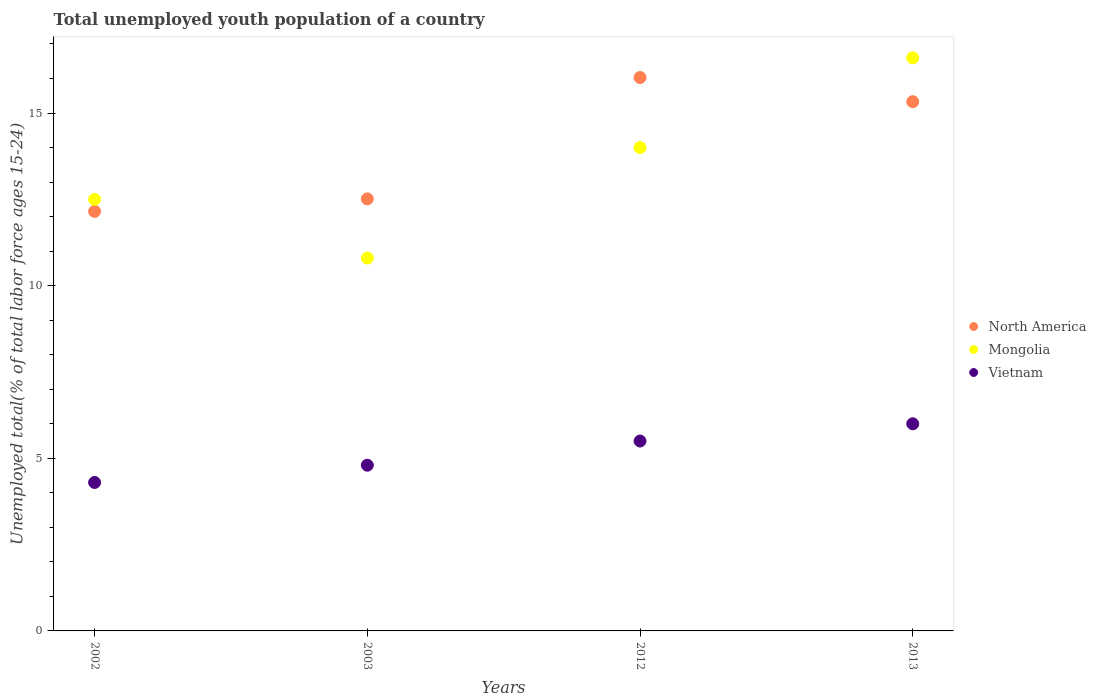Across all years, what is the maximum percentage of total unemployed youth population of a country in North America?
Your response must be concise. 16.03. Across all years, what is the minimum percentage of total unemployed youth population of a country in Mongolia?
Keep it short and to the point. 10.8. In which year was the percentage of total unemployed youth population of a country in Vietnam maximum?
Your answer should be compact. 2013. What is the total percentage of total unemployed youth population of a country in Vietnam in the graph?
Your answer should be very brief. 20.6. What is the difference between the percentage of total unemployed youth population of a country in Vietnam in 2003 and that in 2013?
Provide a short and direct response. -1.2. What is the difference between the percentage of total unemployed youth population of a country in Mongolia in 2013 and the percentage of total unemployed youth population of a country in North America in 2012?
Keep it short and to the point. 0.57. What is the average percentage of total unemployed youth population of a country in Vietnam per year?
Offer a terse response. 5.15. In the year 2002, what is the difference between the percentage of total unemployed youth population of a country in North America and percentage of total unemployed youth population of a country in Mongolia?
Offer a very short reply. -0.35. In how many years, is the percentage of total unemployed youth population of a country in North America greater than 11 %?
Give a very brief answer. 4. What is the ratio of the percentage of total unemployed youth population of a country in North America in 2002 to that in 2003?
Provide a short and direct response. 0.97. Is the difference between the percentage of total unemployed youth population of a country in North America in 2003 and 2013 greater than the difference between the percentage of total unemployed youth population of a country in Mongolia in 2003 and 2013?
Provide a succinct answer. Yes. What is the difference between the highest and the second highest percentage of total unemployed youth population of a country in Mongolia?
Make the answer very short. 2.6. What is the difference between the highest and the lowest percentage of total unemployed youth population of a country in Mongolia?
Make the answer very short. 5.8. In how many years, is the percentage of total unemployed youth population of a country in North America greater than the average percentage of total unemployed youth population of a country in North America taken over all years?
Offer a very short reply. 2. Does the percentage of total unemployed youth population of a country in Mongolia monotonically increase over the years?
Give a very brief answer. No. Is the percentage of total unemployed youth population of a country in North America strictly greater than the percentage of total unemployed youth population of a country in Mongolia over the years?
Give a very brief answer. No. Does the graph contain grids?
Your answer should be compact. No. Where does the legend appear in the graph?
Give a very brief answer. Center right. What is the title of the graph?
Your answer should be compact. Total unemployed youth population of a country. What is the label or title of the Y-axis?
Offer a very short reply. Unemployed total(% of total labor force ages 15-24). What is the Unemployed total(% of total labor force ages 15-24) in North America in 2002?
Give a very brief answer. 12.15. What is the Unemployed total(% of total labor force ages 15-24) in Vietnam in 2002?
Your response must be concise. 4.3. What is the Unemployed total(% of total labor force ages 15-24) in North America in 2003?
Make the answer very short. 12.51. What is the Unemployed total(% of total labor force ages 15-24) of Mongolia in 2003?
Offer a very short reply. 10.8. What is the Unemployed total(% of total labor force ages 15-24) in Vietnam in 2003?
Your answer should be very brief. 4.8. What is the Unemployed total(% of total labor force ages 15-24) in North America in 2012?
Make the answer very short. 16.03. What is the Unemployed total(% of total labor force ages 15-24) of Mongolia in 2012?
Keep it short and to the point. 14. What is the Unemployed total(% of total labor force ages 15-24) in North America in 2013?
Provide a short and direct response. 15.33. What is the Unemployed total(% of total labor force ages 15-24) of Mongolia in 2013?
Provide a short and direct response. 16.6. What is the Unemployed total(% of total labor force ages 15-24) of Vietnam in 2013?
Give a very brief answer. 6. Across all years, what is the maximum Unemployed total(% of total labor force ages 15-24) in North America?
Keep it short and to the point. 16.03. Across all years, what is the maximum Unemployed total(% of total labor force ages 15-24) in Mongolia?
Provide a succinct answer. 16.6. Across all years, what is the minimum Unemployed total(% of total labor force ages 15-24) of North America?
Make the answer very short. 12.15. Across all years, what is the minimum Unemployed total(% of total labor force ages 15-24) in Mongolia?
Offer a very short reply. 10.8. Across all years, what is the minimum Unemployed total(% of total labor force ages 15-24) in Vietnam?
Provide a succinct answer. 4.3. What is the total Unemployed total(% of total labor force ages 15-24) in North America in the graph?
Ensure brevity in your answer.  56.02. What is the total Unemployed total(% of total labor force ages 15-24) of Mongolia in the graph?
Keep it short and to the point. 53.9. What is the total Unemployed total(% of total labor force ages 15-24) of Vietnam in the graph?
Ensure brevity in your answer.  20.6. What is the difference between the Unemployed total(% of total labor force ages 15-24) of North America in 2002 and that in 2003?
Your response must be concise. -0.36. What is the difference between the Unemployed total(% of total labor force ages 15-24) in North America in 2002 and that in 2012?
Provide a succinct answer. -3.88. What is the difference between the Unemployed total(% of total labor force ages 15-24) in North America in 2002 and that in 2013?
Ensure brevity in your answer.  -3.18. What is the difference between the Unemployed total(% of total labor force ages 15-24) of Vietnam in 2002 and that in 2013?
Provide a succinct answer. -1.7. What is the difference between the Unemployed total(% of total labor force ages 15-24) in North America in 2003 and that in 2012?
Your response must be concise. -3.52. What is the difference between the Unemployed total(% of total labor force ages 15-24) of Mongolia in 2003 and that in 2012?
Your answer should be very brief. -3.2. What is the difference between the Unemployed total(% of total labor force ages 15-24) of North America in 2003 and that in 2013?
Provide a short and direct response. -2.82. What is the difference between the Unemployed total(% of total labor force ages 15-24) of Mongolia in 2003 and that in 2013?
Your response must be concise. -5.8. What is the difference between the Unemployed total(% of total labor force ages 15-24) of North America in 2012 and that in 2013?
Ensure brevity in your answer.  0.7. What is the difference between the Unemployed total(% of total labor force ages 15-24) of Mongolia in 2012 and that in 2013?
Keep it short and to the point. -2.6. What is the difference between the Unemployed total(% of total labor force ages 15-24) of Vietnam in 2012 and that in 2013?
Your answer should be compact. -0.5. What is the difference between the Unemployed total(% of total labor force ages 15-24) in North America in 2002 and the Unemployed total(% of total labor force ages 15-24) in Mongolia in 2003?
Your answer should be very brief. 1.35. What is the difference between the Unemployed total(% of total labor force ages 15-24) in North America in 2002 and the Unemployed total(% of total labor force ages 15-24) in Vietnam in 2003?
Your response must be concise. 7.35. What is the difference between the Unemployed total(% of total labor force ages 15-24) of Mongolia in 2002 and the Unemployed total(% of total labor force ages 15-24) of Vietnam in 2003?
Keep it short and to the point. 7.7. What is the difference between the Unemployed total(% of total labor force ages 15-24) of North America in 2002 and the Unemployed total(% of total labor force ages 15-24) of Mongolia in 2012?
Offer a terse response. -1.85. What is the difference between the Unemployed total(% of total labor force ages 15-24) in North America in 2002 and the Unemployed total(% of total labor force ages 15-24) in Vietnam in 2012?
Offer a very short reply. 6.65. What is the difference between the Unemployed total(% of total labor force ages 15-24) of Mongolia in 2002 and the Unemployed total(% of total labor force ages 15-24) of Vietnam in 2012?
Your response must be concise. 7. What is the difference between the Unemployed total(% of total labor force ages 15-24) in North America in 2002 and the Unemployed total(% of total labor force ages 15-24) in Mongolia in 2013?
Offer a terse response. -4.45. What is the difference between the Unemployed total(% of total labor force ages 15-24) of North America in 2002 and the Unemployed total(% of total labor force ages 15-24) of Vietnam in 2013?
Your response must be concise. 6.15. What is the difference between the Unemployed total(% of total labor force ages 15-24) in North America in 2003 and the Unemployed total(% of total labor force ages 15-24) in Mongolia in 2012?
Your response must be concise. -1.49. What is the difference between the Unemployed total(% of total labor force ages 15-24) in North America in 2003 and the Unemployed total(% of total labor force ages 15-24) in Vietnam in 2012?
Keep it short and to the point. 7.01. What is the difference between the Unemployed total(% of total labor force ages 15-24) of North America in 2003 and the Unemployed total(% of total labor force ages 15-24) of Mongolia in 2013?
Provide a succinct answer. -4.09. What is the difference between the Unemployed total(% of total labor force ages 15-24) of North America in 2003 and the Unemployed total(% of total labor force ages 15-24) of Vietnam in 2013?
Make the answer very short. 6.51. What is the difference between the Unemployed total(% of total labor force ages 15-24) in North America in 2012 and the Unemployed total(% of total labor force ages 15-24) in Mongolia in 2013?
Provide a short and direct response. -0.57. What is the difference between the Unemployed total(% of total labor force ages 15-24) in North America in 2012 and the Unemployed total(% of total labor force ages 15-24) in Vietnam in 2013?
Keep it short and to the point. 10.03. What is the difference between the Unemployed total(% of total labor force ages 15-24) in Mongolia in 2012 and the Unemployed total(% of total labor force ages 15-24) in Vietnam in 2013?
Keep it short and to the point. 8. What is the average Unemployed total(% of total labor force ages 15-24) of North America per year?
Offer a very short reply. 14.01. What is the average Unemployed total(% of total labor force ages 15-24) in Mongolia per year?
Offer a terse response. 13.47. What is the average Unemployed total(% of total labor force ages 15-24) in Vietnam per year?
Make the answer very short. 5.15. In the year 2002, what is the difference between the Unemployed total(% of total labor force ages 15-24) in North America and Unemployed total(% of total labor force ages 15-24) in Mongolia?
Provide a short and direct response. -0.35. In the year 2002, what is the difference between the Unemployed total(% of total labor force ages 15-24) of North America and Unemployed total(% of total labor force ages 15-24) of Vietnam?
Offer a very short reply. 7.85. In the year 2002, what is the difference between the Unemployed total(% of total labor force ages 15-24) in Mongolia and Unemployed total(% of total labor force ages 15-24) in Vietnam?
Provide a short and direct response. 8.2. In the year 2003, what is the difference between the Unemployed total(% of total labor force ages 15-24) in North America and Unemployed total(% of total labor force ages 15-24) in Mongolia?
Offer a very short reply. 1.71. In the year 2003, what is the difference between the Unemployed total(% of total labor force ages 15-24) of North America and Unemployed total(% of total labor force ages 15-24) of Vietnam?
Offer a terse response. 7.71. In the year 2003, what is the difference between the Unemployed total(% of total labor force ages 15-24) of Mongolia and Unemployed total(% of total labor force ages 15-24) of Vietnam?
Ensure brevity in your answer.  6. In the year 2012, what is the difference between the Unemployed total(% of total labor force ages 15-24) of North America and Unemployed total(% of total labor force ages 15-24) of Mongolia?
Offer a terse response. 2.03. In the year 2012, what is the difference between the Unemployed total(% of total labor force ages 15-24) of North America and Unemployed total(% of total labor force ages 15-24) of Vietnam?
Offer a very short reply. 10.53. In the year 2013, what is the difference between the Unemployed total(% of total labor force ages 15-24) in North America and Unemployed total(% of total labor force ages 15-24) in Mongolia?
Your answer should be very brief. -1.27. In the year 2013, what is the difference between the Unemployed total(% of total labor force ages 15-24) of North America and Unemployed total(% of total labor force ages 15-24) of Vietnam?
Provide a short and direct response. 9.33. What is the ratio of the Unemployed total(% of total labor force ages 15-24) of North America in 2002 to that in 2003?
Make the answer very short. 0.97. What is the ratio of the Unemployed total(% of total labor force ages 15-24) in Mongolia in 2002 to that in 2003?
Your answer should be compact. 1.16. What is the ratio of the Unemployed total(% of total labor force ages 15-24) of Vietnam in 2002 to that in 2003?
Your response must be concise. 0.9. What is the ratio of the Unemployed total(% of total labor force ages 15-24) in North America in 2002 to that in 2012?
Ensure brevity in your answer.  0.76. What is the ratio of the Unemployed total(% of total labor force ages 15-24) of Mongolia in 2002 to that in 2012?
Ensure brevity in your answer.  0.89. What is the ratio of the Unemployed total(% of total labor force ages 15-24) in Vietnam in 2002 to that in 2012?
Ensure brevity in your answer.  0.78. What is the ratio of the Unemployed total(% of total labor force ages 15-24) of North America in 2002 to that in 2013?
Make the answer very short. 0.79. What is the ratio of the Unemployed total(% of total labor force ages 15-24) in Mongolia in 2002 to that in 2013?
Provide a short and direct response. 0.75. What is the ratio of the Unemployed total(% of total labor force ages 15-24) in Vietnam in 2002 to that in 2013?
Make the answer very short. 0.72. What is the ratio of the Unemployed total(% of total labor force ages 15-24) of North America in 2003 to that in 2012?
Your response must be concise. 0.78. What is the ratio of the Unemployed total(% of total labor force ages 15-24) in Mongolia in 2003 to that in 2012?
Your answer should be very brief. 0.77. What is the ratio of the Unemployed total(% of total labor force ages 15-24) in Vietnam in 2003 to that in 2012?
Ensure brevity in your answer.  0.87. What is the ratio of the Unemployed total(% of total labor force ages 15-24) in North America in 2003 to that in 2013?
Your response must be concise. 0.82. What is the ratio of the Unemployed total(% of total labor force ages 15-24) of Mongolia in 2003 to that in 2013?
Give a very brief answer. 0.65. What is the ratio of the Unemployed total(% of total labor force ages 15-24) of Vietnam in 2003 to that in 2013?
Offer a very short reply. 0.8. What is the ratio of the Unemployed total(% of total labor force ages 15-24) in North America in 2012 to that in 2013?
Make the answer very short. 1.05. What is the ratio of the Unemployed total(% of total labor force ages 15-24) of Mongolia in 2012 to that in 2013?
Keep it short and to the point. 0.84. What is the ratio of the Unemployed total(% of total labor force ages 15-24) in Vietnam in 2012 to that in 2013?
Make the answer very short. 0.92. What is the difference between the highest and the second highest Unemployed total(% of total labor force ages 15-24) of North America?
Provide a succinct answer. 0.7. What is the difference between the highest and the second highest Unemployed total(% of total labor force ages 15-24) in Mongolia?
Give a very brief answer. 2.6. What is the difference between the highest and the lowest Unemployed total(% of total labor force ages 15-24) in North America?
Offer a terse response. 3.88. What is the difference between the highest and the lowest Unemployed total(% of total labor force ages 15-24) in Vietnam?
Ensure brevity in your answer.  1.7. 